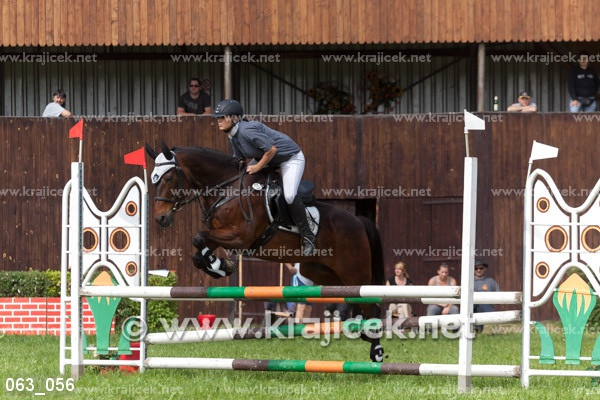Describe the objects in this image and their specific colors. I can see horse in salmon, black, maroon, gray, and darkgray tones, people in brown, black, gray, and lavender tones, people in salmon, black, gray, and darkgray tones, people in salmon, black, brown, and maroon tones, and people in salmon, lightpink, darkgray, and gray tones in this image. 